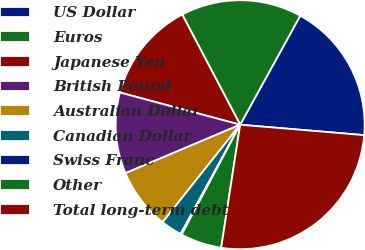<chart> <loc_0><loc_0><loc_500><loc_500><pie_chart><fcel>US Dollar<fcel>Euros<fcel>Japanese Yen<fcel>British Pound<fcel>Australian Dollar<fcel>Canadian Dollar<fcel>Swiss Franc<fcel>Other<fcel>Total long-term debt<nl><fcel>18.32%<fcel>15.72%<fcel>13.13%<fcel>10.53%<fcel>7.94%<fcel>2.75%<fcel>0.16%<fcel>5.35%<fcel>26.1%<nl></chart> 